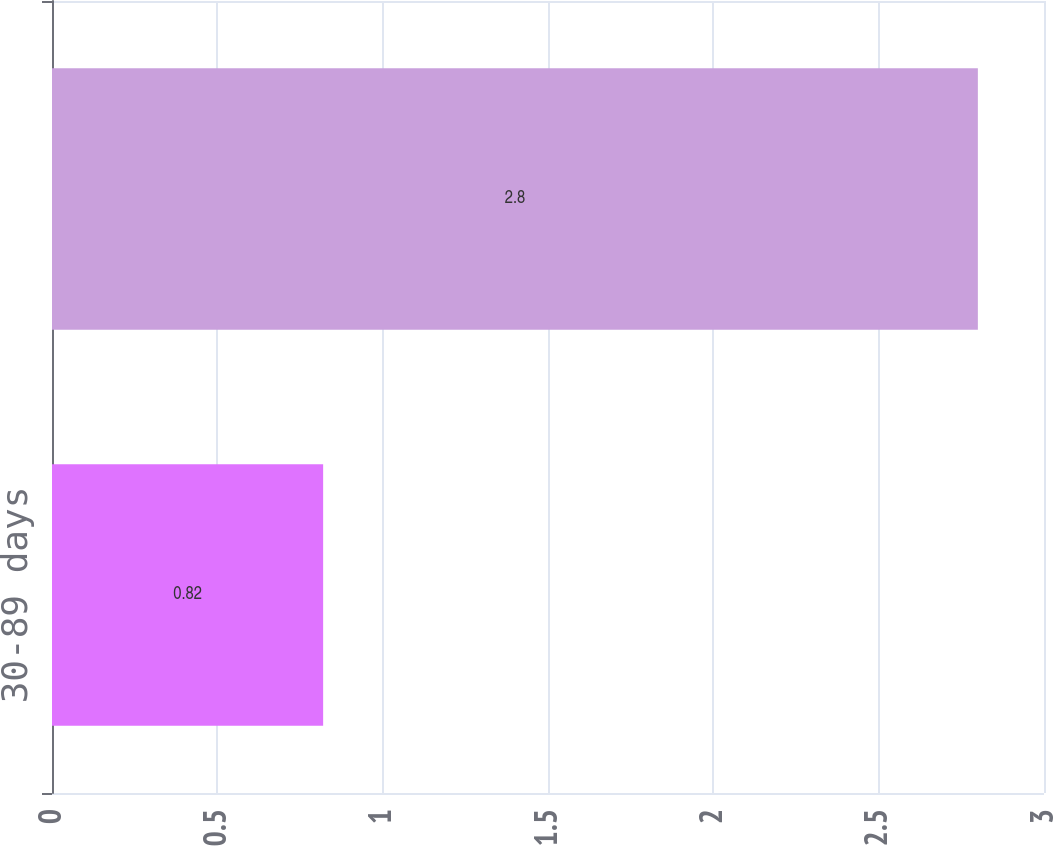<chart> <loc_0><loc_0><loc_500><loc_500><bar_chart><fcel>30-89 days<fcel>90 days or more<nl><fcel>0.82<fcel>2.8<nl></chart> 